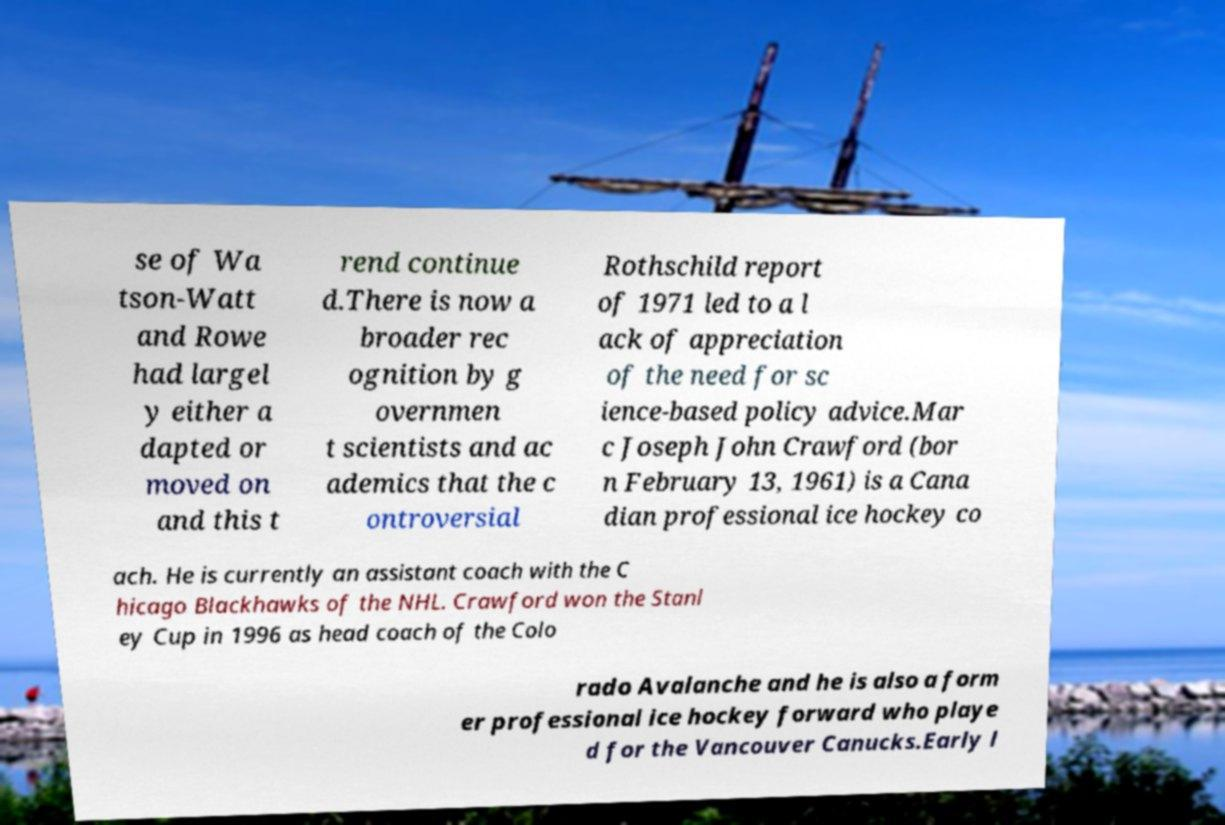Please read and relay the text visible in this image. What does it say? se of Wa tson-Watt and Rowe had largel y either a dapted or moved on and this t rend continue d.There is now a broader rec ognition by g overnmen t scientists and ac ademics that the c ontroversial Rothschild report of 1971 led to a l ack of appreciation of the need for sc ience-based policy advice.Mar c Joseph John Crawford (bor n February 13, 1961) is a Cana dian professional ice hockey co ach. He is currently an assistant coach with the C hicago Blackhawks of the NHL. Crawford won the Stanl ey Cup in 1996 as head coach of the Colo rado Avalanche and he is also a form er professional ice hockey forward who playe d for the Vancouver Canucks.Early l 